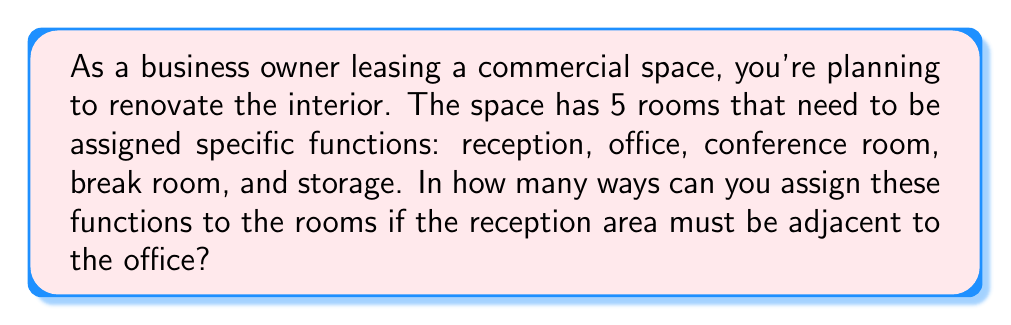What is the answer to this math problem? Let's approach this step-by-step using combinatorial algebra:

1) First, we need to consider the reception and office as one unit, since they must be adjacent. This reduces our problem to arranging 4 units: (reception+office), conference room, break room, and storage.

2) The number of ways to arrange 4 distinct units is given by the permutation formula:
   $$P(4,4) = 4! = 4 \times 3 \times 2 \times 1 = 24$$

3) However, for each of these 24 arrangements, we have 2 ways to arrange the reception and office within their unit (reception-office or office-reception).

4) Therefore, we need to multiply our result by 2:
   $$24 \times 2 = 48$$

5) This can also be expressed using the multiplication principle of counting:
   $$\text{Total arrangements} = (\text{arrangements of 4 units}) \times (\text{arrangements within reception+office unit})$$
   $$= 4! \times 2 = 48$$

Thus, there are 48 possible ways to assign the functions to the rooms while keeping the reception adjacent to the office.
Answer: 48 possible floor plans 